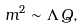<formula> <loc_0><loc_0><loc_500><loc_500>m ^ { 2 } \sim \Lambda \, Q ,</formula> 